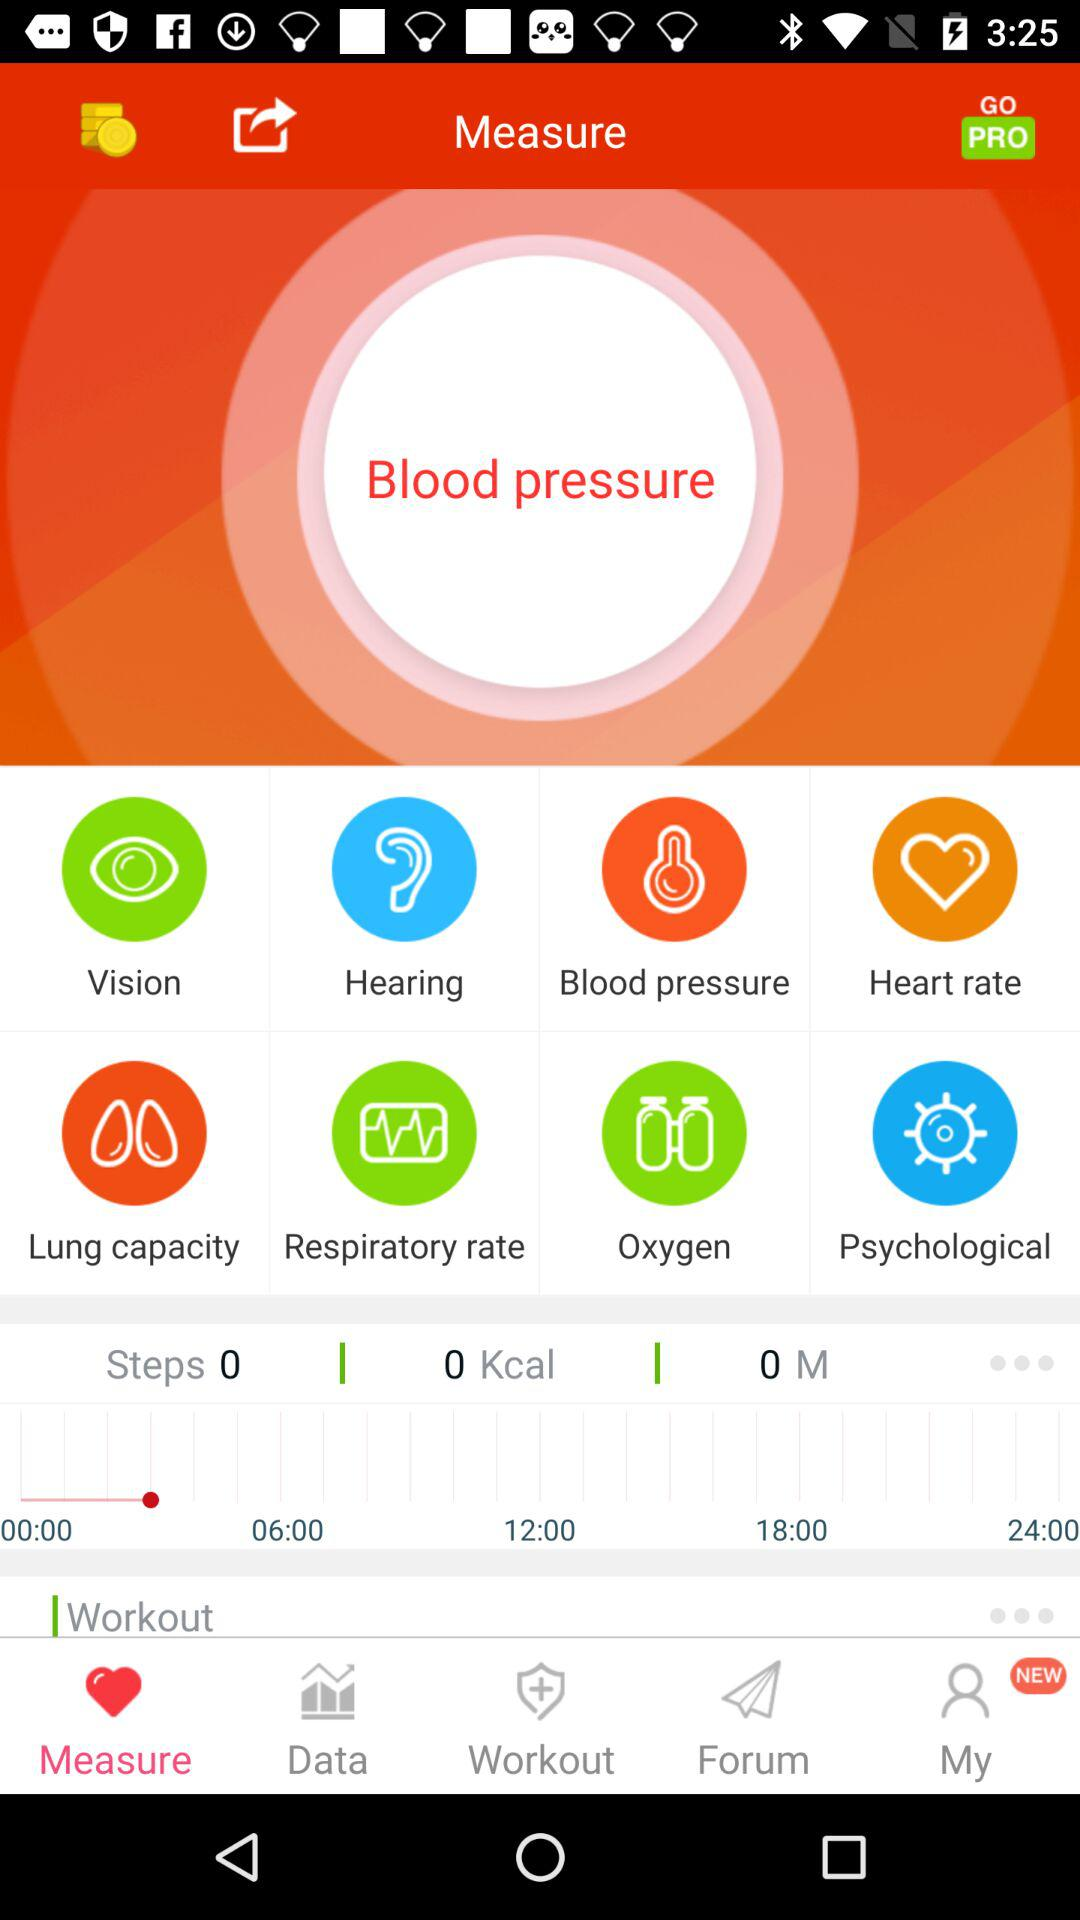How many steps are taken? The number of steps taken is 0. 